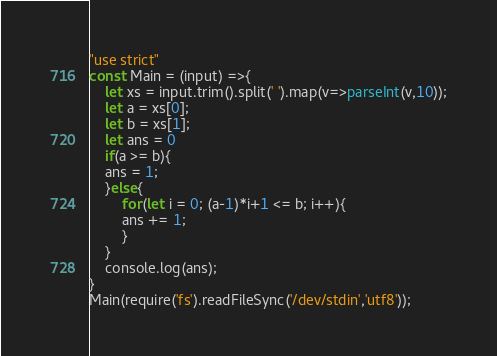<code> <loc_0><loc_0><loc_500><loc_500><_JavaScript_>"use strict"
const Main = (input) =>{
	let xs = input.trim().split(' ').map(v=>parseInt(v,10));
    let a = xs[0];
    let b = xs[1];
    let ans = 0
    if(a >= b){
    ans = 1;
    }else{ 
    	for(let i = 0; (a-1)*i+1 <= b; i++){
    	ans += 1;
    	}
    }
    console.log(ans);
}
Main(require('fs').readFileSync('/dev/stdin','utf8'));
</code> 